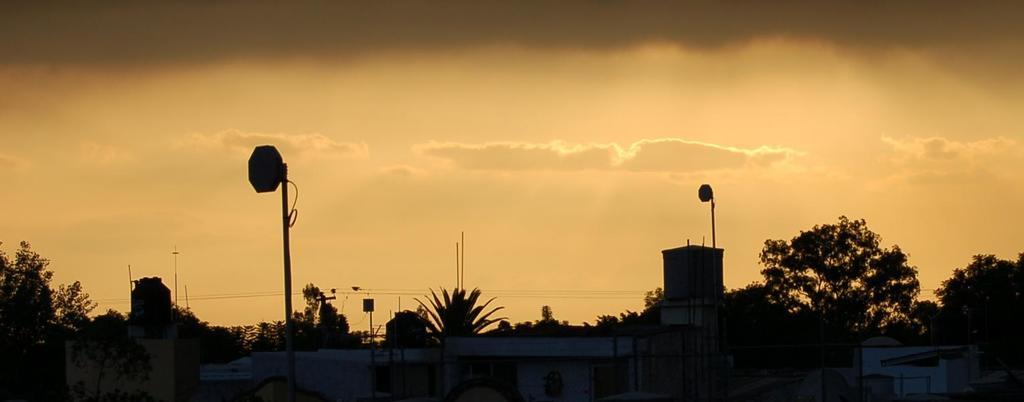What time of day is depicted in the image? The image appears to depict a sunset in the evening. What structures are located at the bottom of the image? There are houses at the bottom of the image. What type of vegetation is present at the bottom of the image? There are trees at the bottom of the image. What is visible at the top of the image? The sky is visible at the top of the image. How many spiders are sitting on the sofa in the image? There is no sofa present in the image, and therefore no spiders can be observed. 